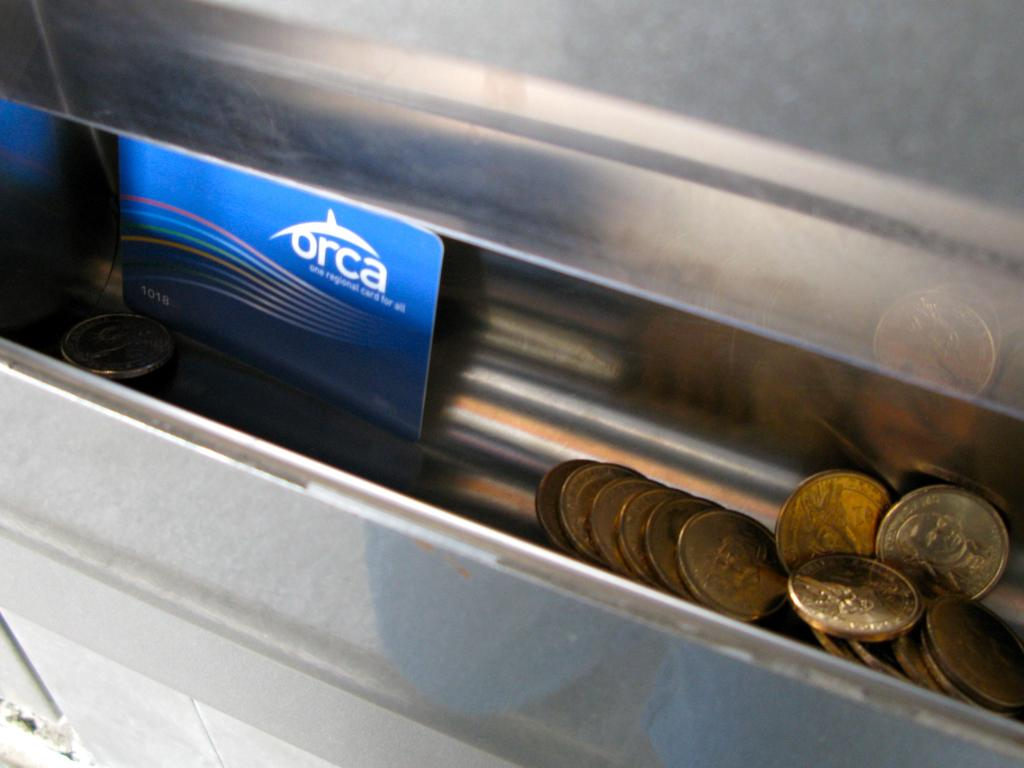<image>
Render a clear and concise summary of the photo. Some change and a card with the word "orca" on it are in a tray. 